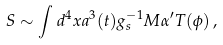<formula> <loc_0><loc_0><loc_500><loc_500>S \sim \int d ^ { 4 } x a ^ { 3 } ( t ) g _ { s } ^ { - 1 } M \alpha ^ { \prime } T ( \phi ) \, ,</formula> 